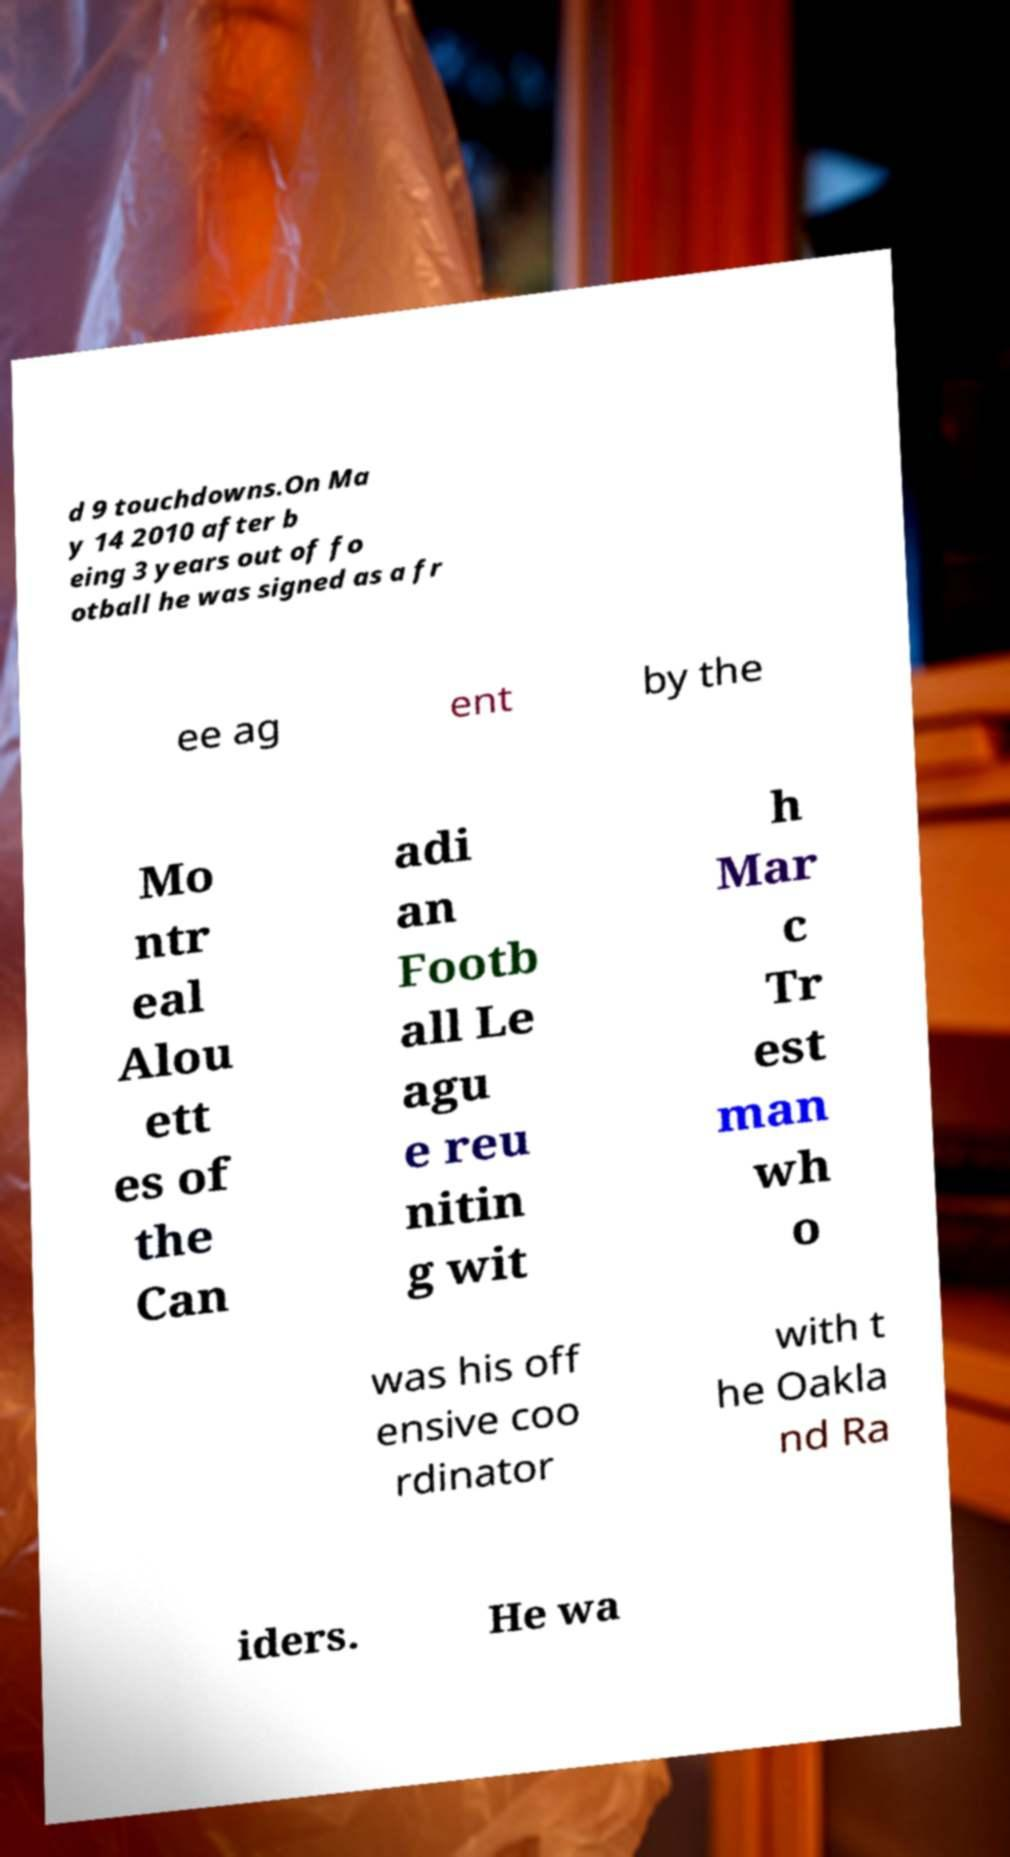Could you extract and type out the text from this image? d 9 touchdowns.On Ma y 14 2010 after b eing 3 years out of fo otball he was signed as a fr ee ag ent by the Mo ntr eal Alou ett es of the Can adi an Footb all Le agu e reu nitin g wit h Mar c Tr est man wh o was his off ensive coo rdinator with t he Oakla nd Ra iders. He wa 